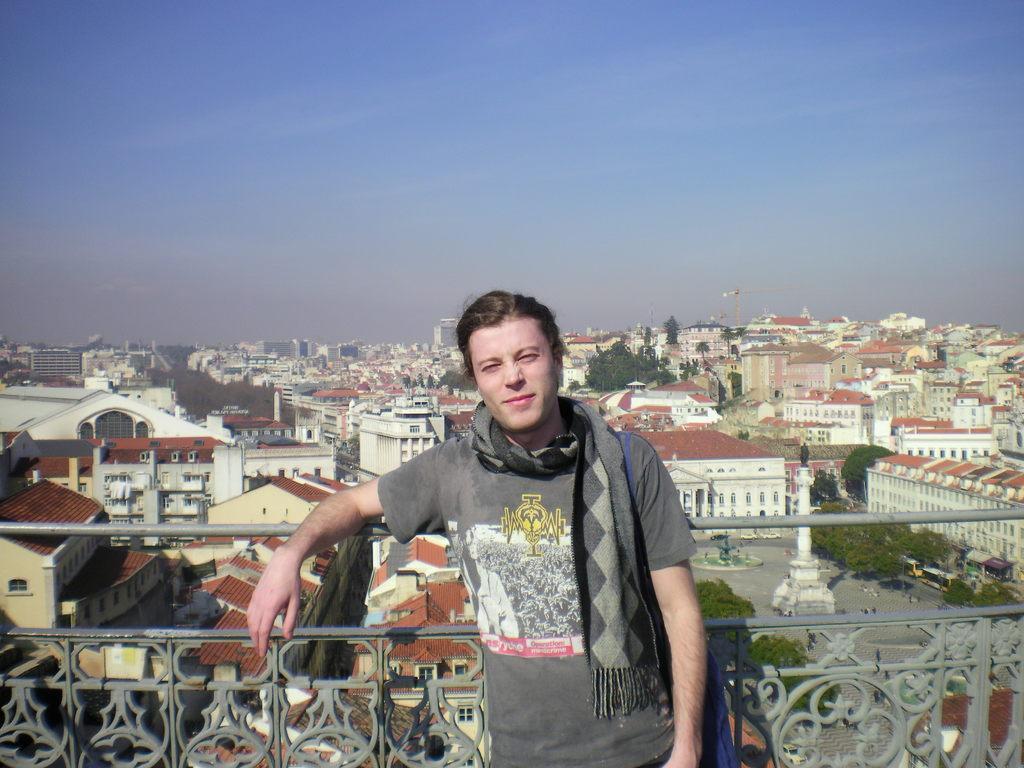Please provide a concise description of this image. In this image in the foreground there is one person who is standing, and in the background there are some houses, buildings, trees and road. And also on the road there are some vehicles, on the top of the image there is sky. 